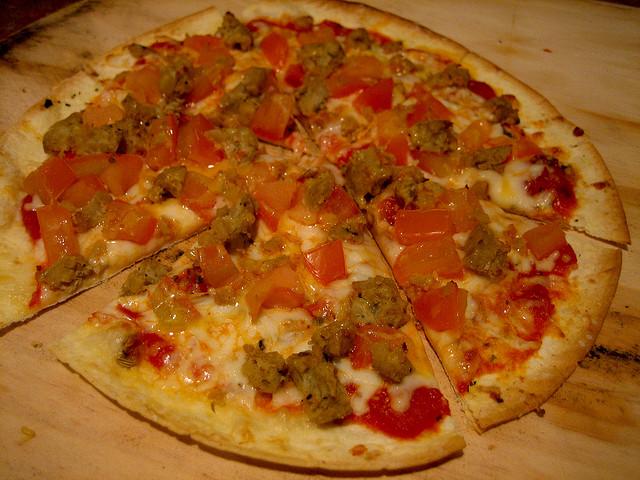What are the brown things on top of the pizza?
Write a very short answer. Sausage. Does the pizza look burnt?
Quick response, please. No. How many slices of pizza are there?
Be succinct. 7. Is this a thin crust pizza?
Write a very short answer. Yes. What is pia on?
Answer briefly. Table. Did someone have a liberal hand with the cheese?
Short answer required. Yes. How many slices is the pizza divided into?
Keep it brief. 6. What does the pizza have?
Answer briefly. Sausage. Is this a pizza that would appeal to someone who doesn't like trying new things?
Give a very brief answer. No. Is this a vegetarian pizza?
Quick response, please. No. Is this deep dish or thin crust?
Quick response, please. Thin crust. Is this pizza vegetarian?
Be succinct. No. Are there fried eggs on the pizza?
Write a very short answer. No. Has this pizza been cut into slices?
Answer briefly. Yes. What is the pizza on?
Give a very brief answer. Wood. What kind of pizza is this?
Give a very brief answer. Sausage. 